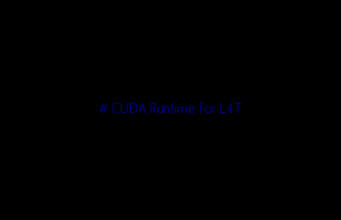<code> <loc_0><loc_0><loc_500><loc_500><_Dockerfile_># CUDA Runtime for L4T
</code> 